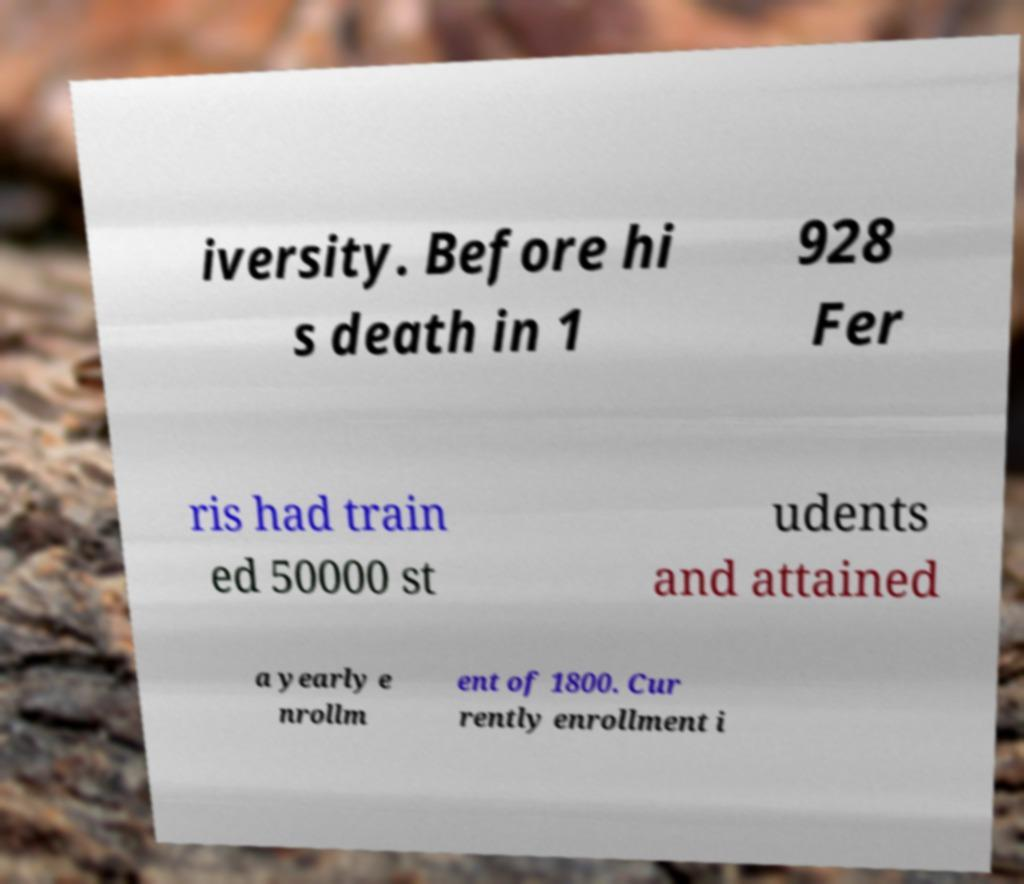Could you assist in decoding the text presented in this image and type it out clearly? iversity. Before hi s death in 1 928 Fer ris had train ed 50000 st udents and attained a yearly e nrollm ent of 1800. Cur rently enrollment i 